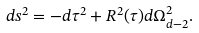<formula> <loc_0><loc_0><loc_500><loc_500>d s ^ { 2 } = - d \tau ^ { 2 } + R ^ { 2 } ( \tau ) d \Omega _ { d - 2 } ^ { 2 } .</formula> 